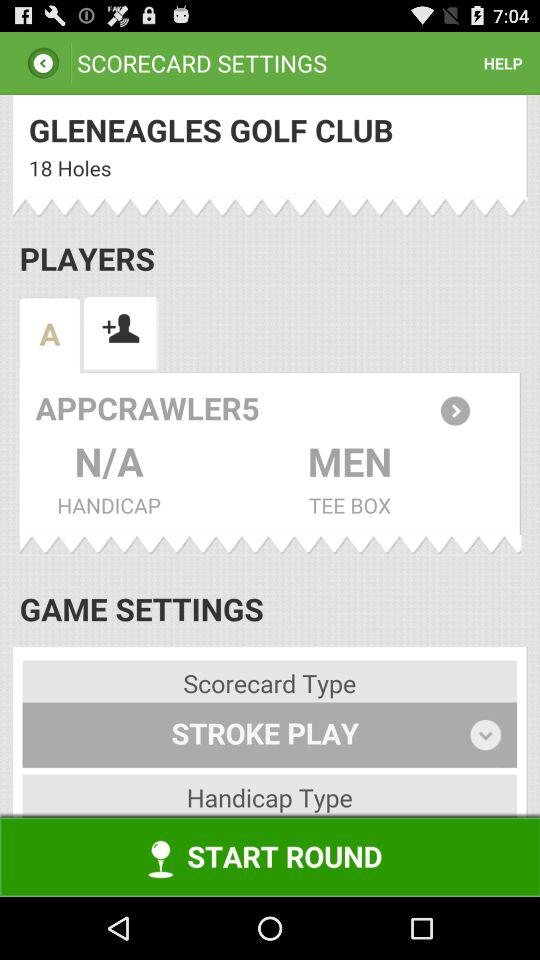How many "Holes" are present on the screen? There are 18 holes. 